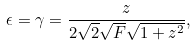Convert formula to latex. <formula><loc_0><loc_0><loc_500><loc_500>\epsilon = \gamma = \frac { z } { 2 \sqrt { 2 } \sqrt { F } \sqrt { 1 + z ^ { 2 } } } ,</formula> 